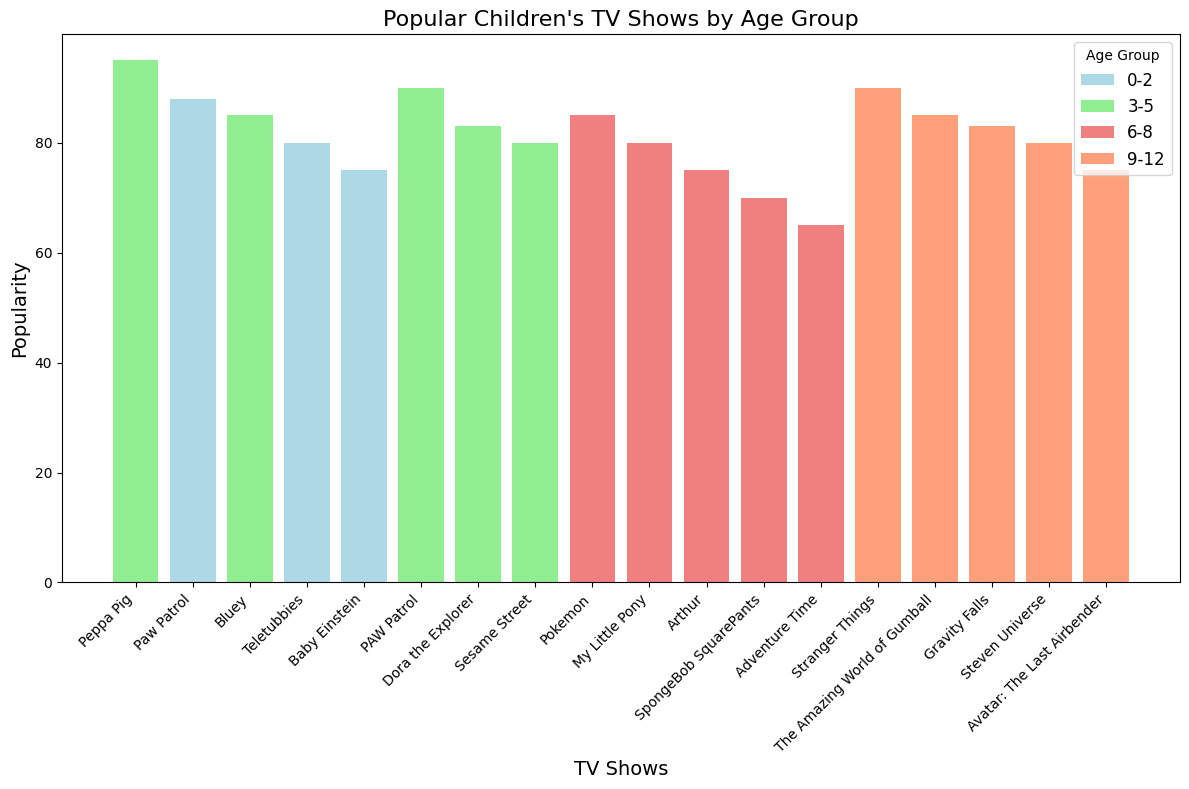Which age group has the most popular show? The most popular show corresponds to the tallest bar in the chart, which is "Peppa Pig" for the age group 3-5 with a popularity score of 95.
Answer: 3-5 How does the popularity of "Peppa Pig" change between age groups? "Peppa Pig" appears in two age groups: 0-2 (92) and 3-5 (95). Therefore, it gets more popular in the higher age group.
Answer: Increases Which age group has the smallest overall popularity range among its shows? To determine the range, subtract the lowest popularity score from the highest within each age group: 0-2 (92-75=17), 3-5 (95-80=15), 6-8 (85-65=20), 9-12 (90-75=15). The smallest range is 15, observed in both the 3-5 and 9-12 age groups.
Answer: 3-5 and 9-12 Compare the popularity of "Bluey" across different age groups. "Bluey" appears in two age groups: 0-2 (85) and 3-5 (85). Its popularity score remains the same in both age groups.
Answer: Stays the same What is the total popularity score for shows in the 6-8 age group? Sum the popularity scores for age group 6-8: 85 (Pokemon) + 80 (My Little Pony) + 75 (Arthur) + 70 (SpongeBob SquarePants) + 65 (Adventure Time) = 375.
Answer: 375 Which show in the 9-12 age group is less popular than "Steven Universe"? In the 9-12 age group, "Steven Universe" has a score of 80. "Avatar: The Last Airbender" has a lower score of 75.
Answer: Avatar: The Last Airbender Which age group has the most shows with a popularity score above 80? Check each age group: 
- 0-2: Peppa Pig (92), Paw Patrol (88), Bluey (85), Teletubbies (80) = 3 shows
- 3-5: Peppa Pig (95), PAW Patrol (90), Bluey (85), Dora the Explorer (83), Sesame Street (80) = 5 shows
- 6-8: Pokemon (85) and My Little Pony (80) = 2 shows
- 9-12: Stranger Things (90), The Amazing World of Gumball (85), and Gravity Falls (83) = 3 shows
Thus, the 3-5 age group has the most.
Answer: 3-5 Which show in the 0-2 age group has the lowest popularity score? Among the shows in the age group 0-2, "Baby Einstein" has the lowest popularity score of 75.
Answer: Baby Einstein Compare the height of the bars for "Pokemon" and "Adventure Time". The bar representing "Pokemon" has a height of 85, while the bar for "Adventure Time" has a height of 65. Thus, "Pokemon" is more popular.
Answer: Pokemon What is the average popularity of shows in the 3-5 age group? Sum the popularity scores for age group 3-5: 95 (Peppa Pig) + 90 (PAW Patrol) + 85 (Bluey) + 83 (Dora the Explorer) + 80 (Sesame Street) = 433. Divide by the number of shows: 433 / 5 = 86.6.
Answer: 86.6 